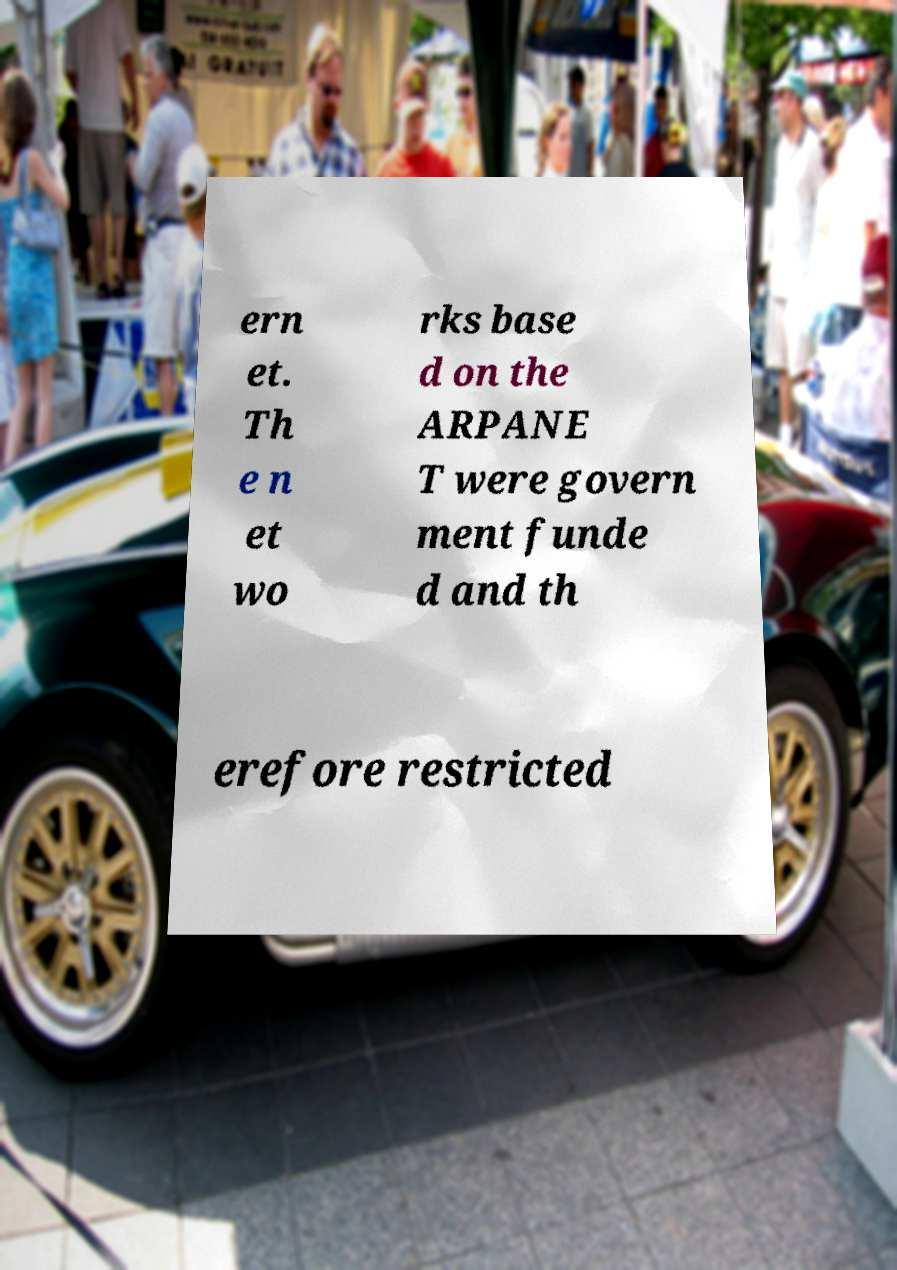Could you extract and type out the text from this image? ern et. Th e n et wo rks base d on the ARPANE T were govern ment funde d and th erefore restricted 